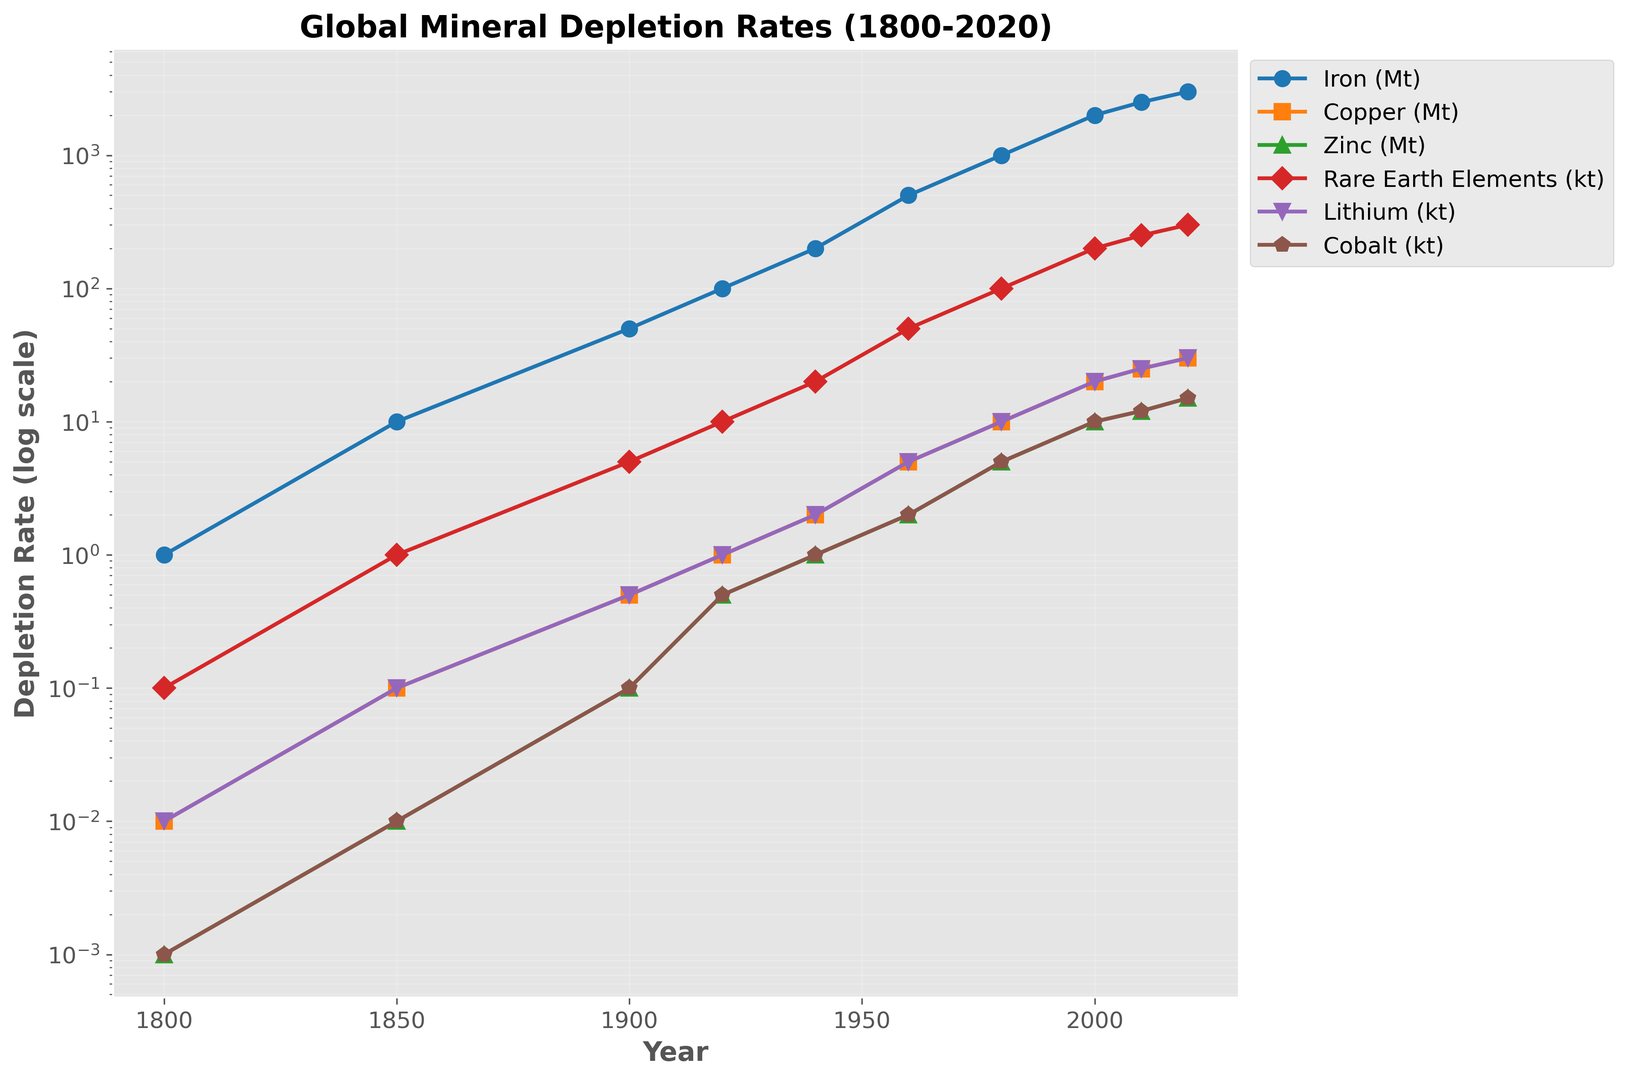What is the depletion rate of Copper in the year 2000? The chart shows a line for Copper with a corresponding marker in the year 2000. By finding the marker on the Copper line for the year 2000, we can see the depletion rate.
Answer: 20 Mt Which mineral had the highest depletion rate in 2020? To determine the mineral with the highest depletion rate in 2020, we look at the end of the lines for each mineral and compare their heights.
Answer: Iron How has the depletion rate of Rare Earth Elements changed from 1800 to 2020? Locate the points on the Rare Earth Elements line for the years 1800 and 2020. Note the change in height, indicating the increase in depletion rate.
Answer: It increased from 0.1 kt to 300 kt How many times greater is the depletion rate of Lithium in 2020 compared to 1900? Find the depletion rate values for Lithium in the years 2020 and 1900. Divide the 2020 rate by the 1900 rate.
Answer: 60 times Which mineral had its depletion rate increase the most between 1960 and 2000? Compare the differences in depletion rates between 1960 and 2000 for all minerals and identify the largest difference.
Answer: Iron How does the depletion rate of Zinc in 1940 compare to that in 1980? Look at the heights of the markers on the Zinc line for the years 1940 and 1980. Compare the two values.
Answer: The depletion rate in 1980 is 5 times that in 1940 In which period did Cobalt's depletion rate increase at the fastest rate? Analyze the slope of the Cobalt line between each consecutive period. The period with the steepest increase indicates the fastest rate.
Answer: 1900 to 1920 What is the average depletion rate of Iron from 1800 to 2020? Sum up the depletion rates of Iron for all years and divide by the number of years.
Answer: 936.36 Mt What is the difference in depletion rates between Copper and Zinc in 1960? Find the depletion rates for Copper and Zinc in 1960 and subtract the Zinc rate from the Copper rate.
Answer: 3 Mt Which mineral shows the least variation in depletion rates over time? Examine the magnitudes of changes in depletion rates for each mineral across all years. Identify the one with the smallest overall variation.
Answer: Zinc 